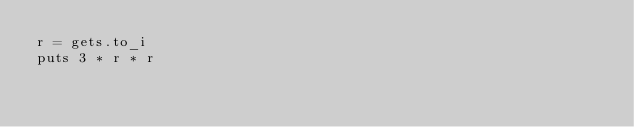<code> <loc_0><loc_0><loc_500><loc_500><_Ruby_>r = gets.to_i
puts 3 * r * r</code> 